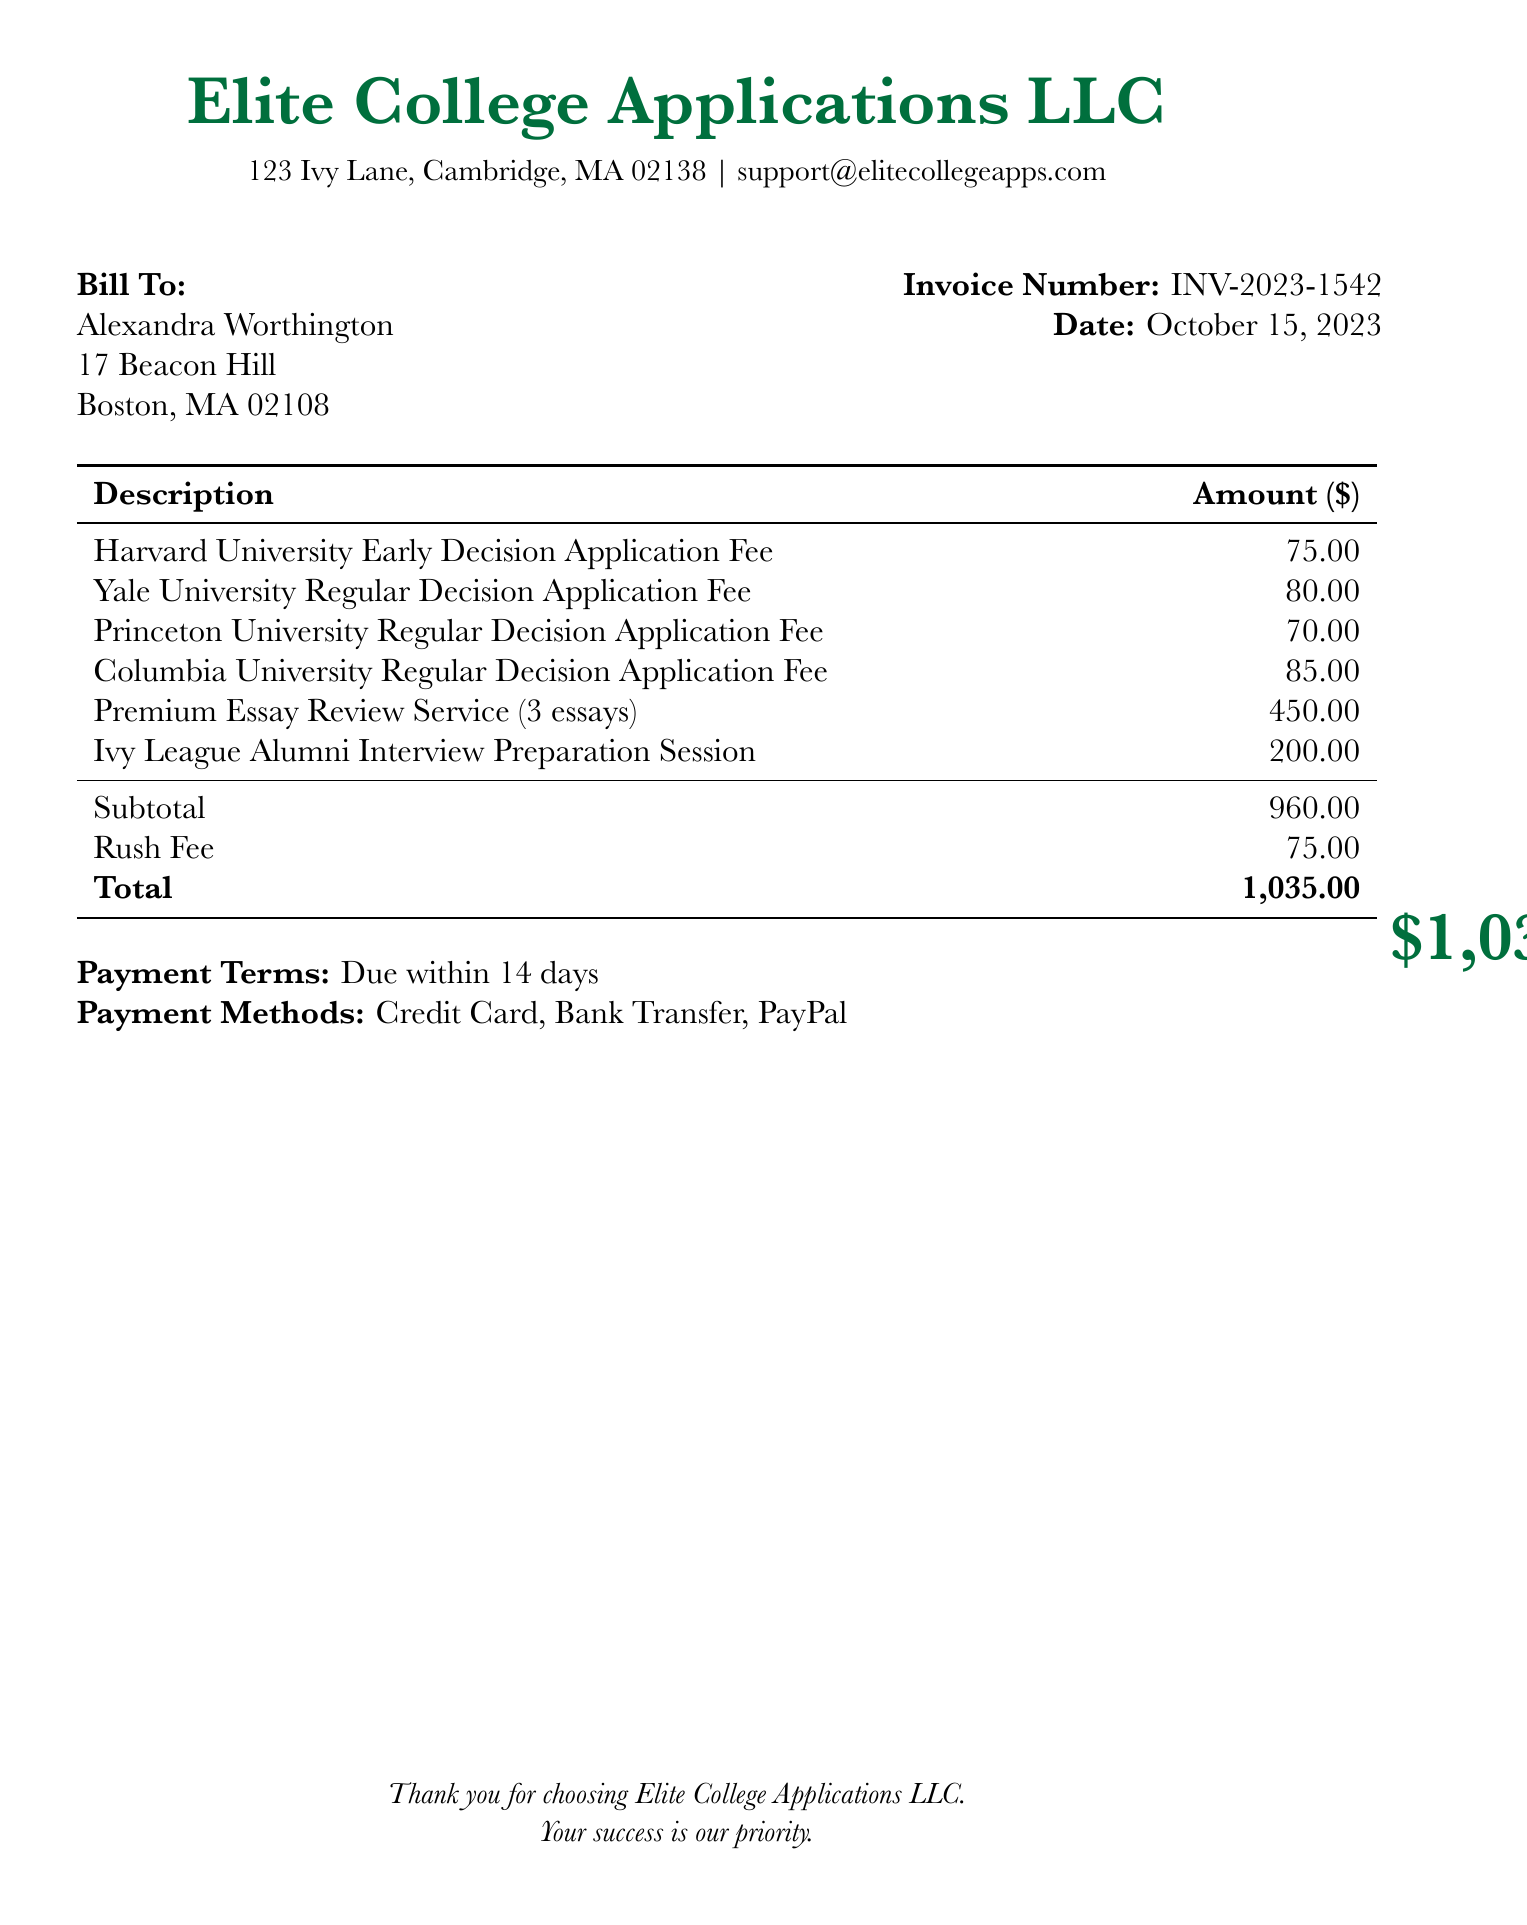What is the name of the company issuing the invoice? The name of the company is listed at the top of the document as "Elite College Applications LLC."
Answer: Elite College Applications LLC What is the total amount due? The total amount due is highlighted in the bottom section of the invoice.
Answer: $1,035.00 What is the invoice number? The invoice number is indicated near the date in the document.
Answer: INV-2023-1542 What is the due date for the payment? The due date is found in the payment terms section, specifying when the payment is expected.
Answer: Within 14 days How many essays are included in the Premium Essay Review Service? The document specifies the number of essays associated with this service.
Answer: 3 essays What is the fee for the Ivy League Alumni Interview Preparation Session? The fee for this session is listed in the breakdown of services provided on the invoice.
Answer: $200.00 What is the subtotal before the rush fee? The subtotal is outlined in the charges before any additional fees are applied to the total.
Answer: $960.00 Which application has the highest fee? The application fees of various institutions are listed in the table, allowing for a comparison of amounts.
Answer: Columbia University Regular Decision Application Fee What payment methods are accepted? The payment methods section outlines the ways the client can make their payment.
Answer: Credit Card, Bank Transfer, PayPal 